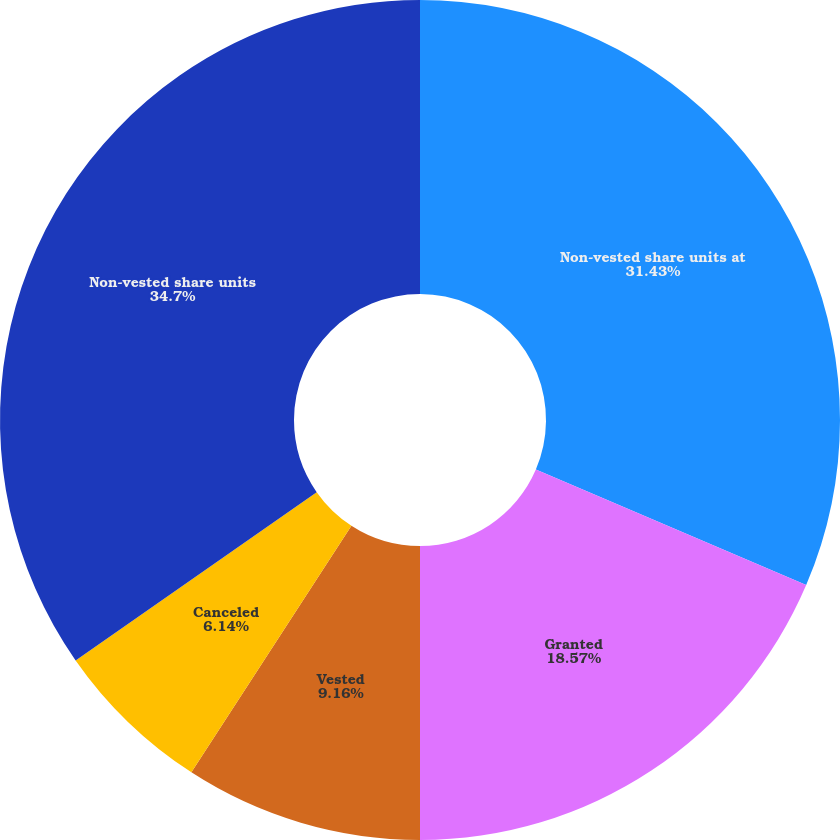Convert chart. <chart><loc_0><loc_0><loc_500><loc_500><pie_chart><fcel>Non-vested share units at<fcel>Granted<fcel>Vested<fcel>Canceled<fcel>Non-vested share units<nl><fcel>31.43%<fcel>18.57%<fcel>9.16%<fcel>6.14%<fcel>34.7%<nl></chart> 